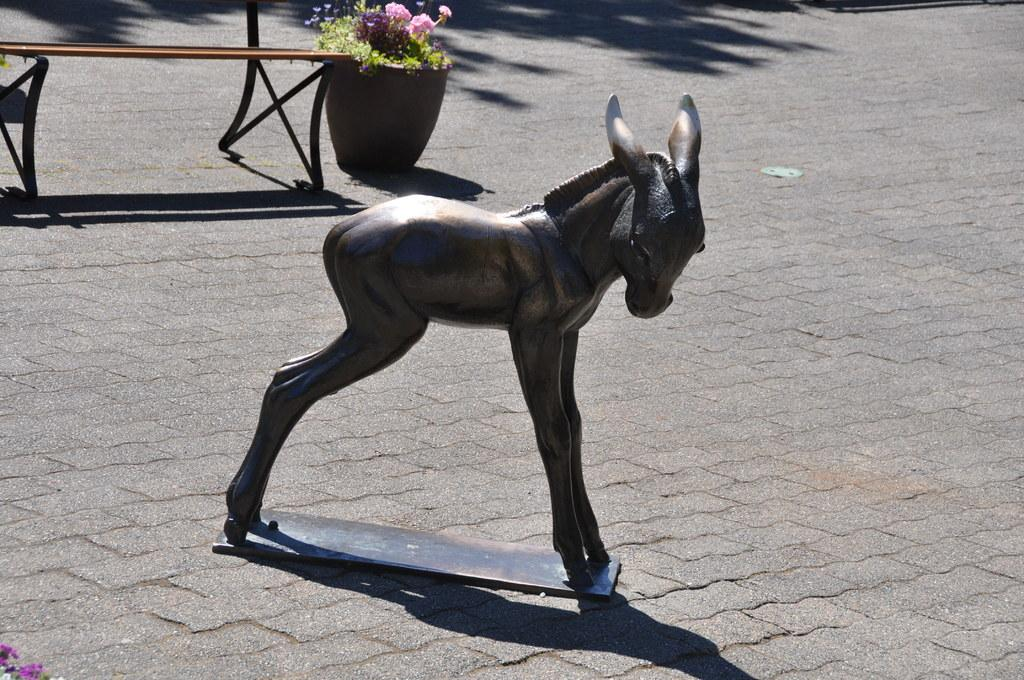What is the main subject of the statue in the image? There is a statue of an animal in the image. What is the statue placed on? The statue is on an object. What type of seating is present in the image? There is a bench in the image. What type of vegetation can be seen in the image? There are plants in the image. Can you describe the floral arrangement in the image? There is a flower in a pot in the image. What can be observed on the ground in the image? There are shadows on the ground in the image. What type of chair is depicted in the image? There is no chair present in the image. How does the statue express disgust in the image? The statue does not express any emotions, including disgust, as it is an inanimate object. 